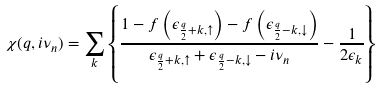Convert formula to latex. <formula><loc_0><loc_0><loc_500><loc_500>\chi ( q , i \nu _ { n } ) = \sum _ { k } \left \{ \frac { 1 - f \left ( \epsilon _ { \frac { q } { 2 } + k , \uparrow } \right ) - f \left ( \epsilon _ { \frac { q } { 2 } - k , \downarrow } \right ) } { \epsilon _ { \frac { q } { 2 } + k , \uparrow } + \epsilon _ { \frac { q } { 2 } - k , \downarrow } - i \nu _ { n } } - \frac { 1 } { 2 \epsilon _ { k } } \right \}</formula> 